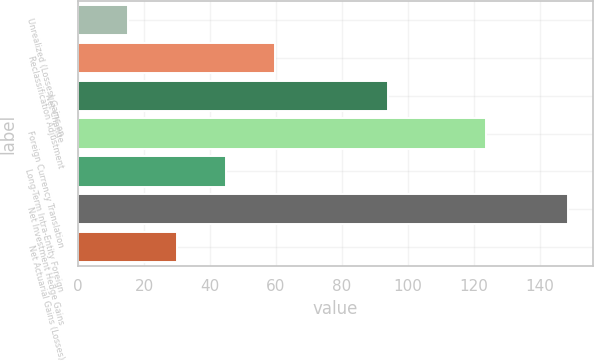Convert chart. <chart><loc_0><loc_0><loc_500><loc_500><bar_chart><fcel>Unrealized (Losses) Gains on<fcel>Reclassification Adjustment<fcel>Net Change<fcel>Foreign Currency Translation<fcel>Long-Term Intra-Entity Foreign<fcel>Net Investment Hedge Gains<fcel>Net Actuarial Gains (Losses)<nl><fcel>15.13<fcel>59.62<fcel>94<fcel>123.66<fcel>44.79<fcel>148.6<fcel>29.96<nl></chart> 